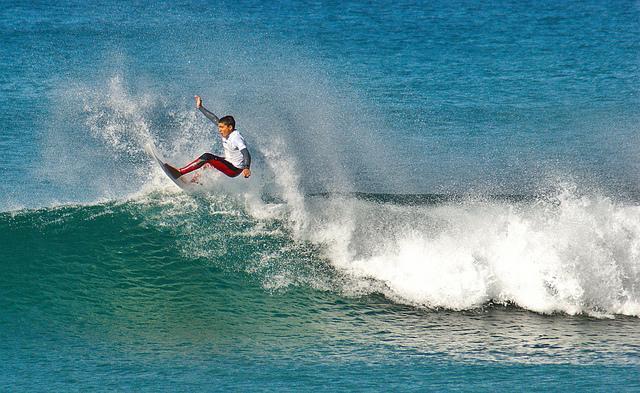How many red bird in this image?
Give a very brief answer. 0. 